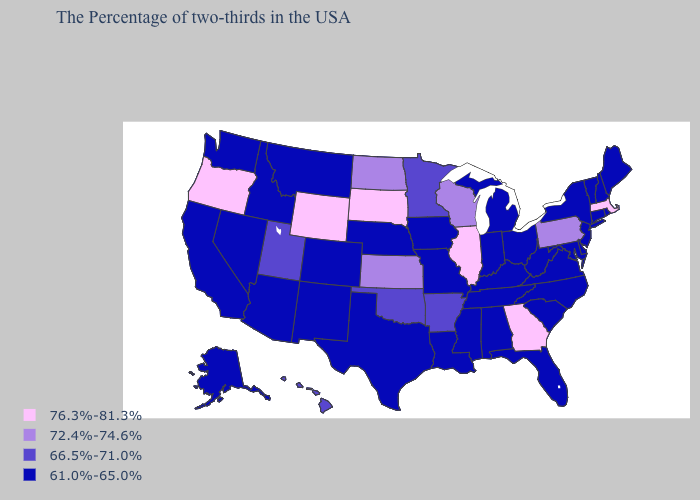Name the states that have a value in the range 76.3%-81.3%?
Answer briefly. Massachusetts, Georgia, Illinois, South Dakota, Wyoming, Oregon. Does Indiana have the lowest value in the MidWest?
Be succinct. Yes. Is the legend a continuous bar?
Write a very short answer. No. Name the states that have a value in the range 76.3%-81.3%?
Concise answer only. Massachusetts, Georgia, Illinois, South Dakota, Wyoming, Oregon. What is the lowest value in the South?
Answer briefly. 61.0%-65.0%. Name the states that have a value in the range 61.0%-65.0%?
Short answer required. Maine, Rhode Island, New Hampshire, Vermont, Connecticut, New York, New Jersey, Delaware, Maryland, Virginia, North Carolina, South Carolina, West Virginia, Ohio, Florida, Michigan, Kentucky, Indiana, Alabama, Tennessee, Mississippi, Louisiana, Missouri, Iowa, Nebraska, Texas, Colorado, New Mexico, Montana, Arizona, Idaho, Nevada, California, Washington, Alaska. Does Utah have the lowest value in the West?
Write a very short answer. No. Name the states that have a value in the range 72.4%-74.6%?
Short answer required. Pennsylvania, Wisconsin, Kansas, North Dakota. Does the map have missing data?
Short answer required. No. What is the value of Montana?
Keep it brief. 61.0%-65.0%. What is the value of New Mexico?
Short answer required. 61.0%-65.0%. Name the states that have a value in the range 72.4%-74.6%?
Answer briefly. Pennsylvania, Wisconsin, Kansas, North Dakota. Does Alaska have a lower value than Oregon?
Give a very brief answer. Yes. Which states have the lowest value in the USA?
Be succinct. Maine, Rhode Island, New Hampshire, Vermont, Connecticut, New York, New Jersey, Delaware, Maryland, Virginia, North Carolina, South Carolina, West Virginia, Ohio, Florida, Michigan, Kentucky, Indiana, Alabama, Tennessee, Mississippi, Louisiana, Missouri, Iowa, Nebraska, Texas, Colorado, New Mexico, Montana, Arizona, Idaho, Nevada, California, Washington, Alaska. What is the highest value in states that border Maryland?
Quick response, please. 72.4%-74.6%. 